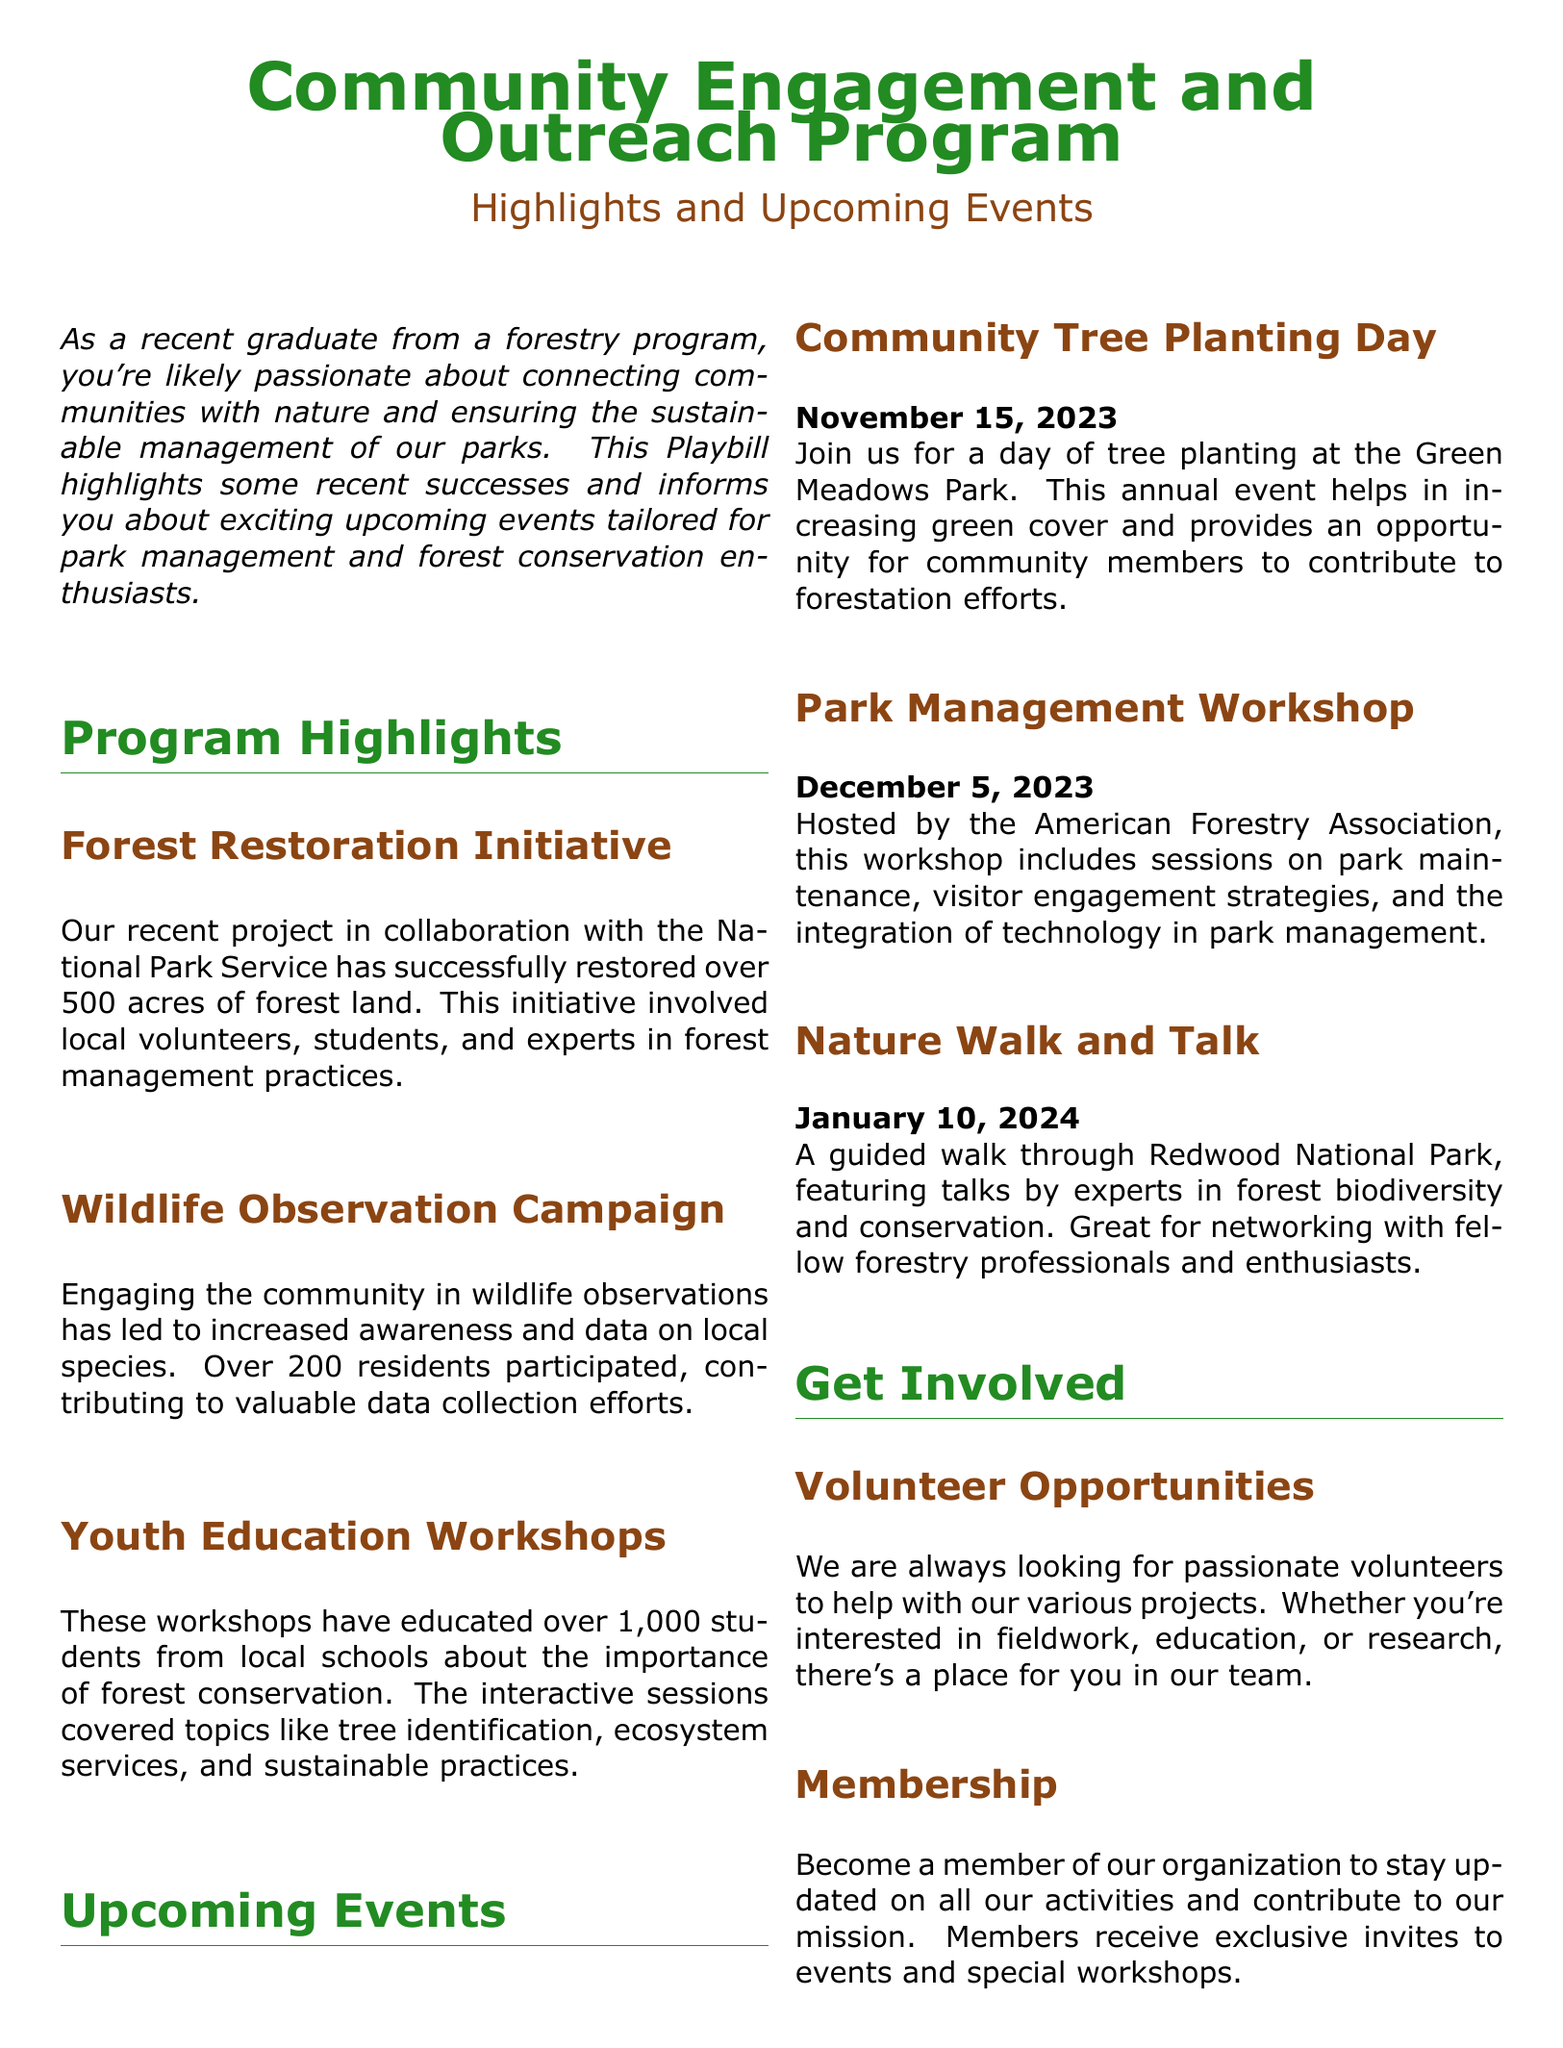What is the name of the initiative that restored over 500 acres of forest land? The name of the initiative mentioned in the document is the Forest Restoration Initiative.
Answer: Forest Restoration Initiative How many residents participated in the Wildlife Observation Campaign? The document states that over 200 residents participated in the Wildlife Observation Campaign.
Answer: 200 When is the Community Tree Planting Day? The document specifies that the Community Tree Planting Day is on November 15, 2023.
Answer: November 15, 2023 What organization is hosting the Park Management Workshop? According to the document, the American Forestry Association is hosting the Park Management Workshop.
Answer: American Forestry Association How many students have been educated through the Youth Education Workshops? The document mentions that over 1,000 students have been educated through these workshops.
Answer: 1,000 What type of event is planned for January 10, 2024? The event planned for January 10, 2024, is a Nature Walk and Talk.
Answer: Nature Walk and Talk What can members receive as mentioned in the document? The document states that members receive exclusive invites to events and special workshops.
Answer: Exclusive invites What should you do to support the cause mentioned in the document? The document suggests that you can support the cause by donating to the programs.
Answer: Donating What is the primary focus of the engagement highlighted in the Playbill? The primary focus of the engagement is on community connection with nature and sustainable park management.
Answer: Community connection with nature 